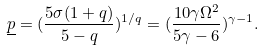<formula> <loc_0><loc_0><loc_500><loc_500>\underline { p } = ( \frac { 5 \sigma ( 1 + q ) } { 5 - q } ) ^ { 1 / q } = ( \frac { 1 0 \gamma \Omega ^ { 2 } } { 5 \gamma - 6 } ) ^ { \gamma - 1 } .</formula> 